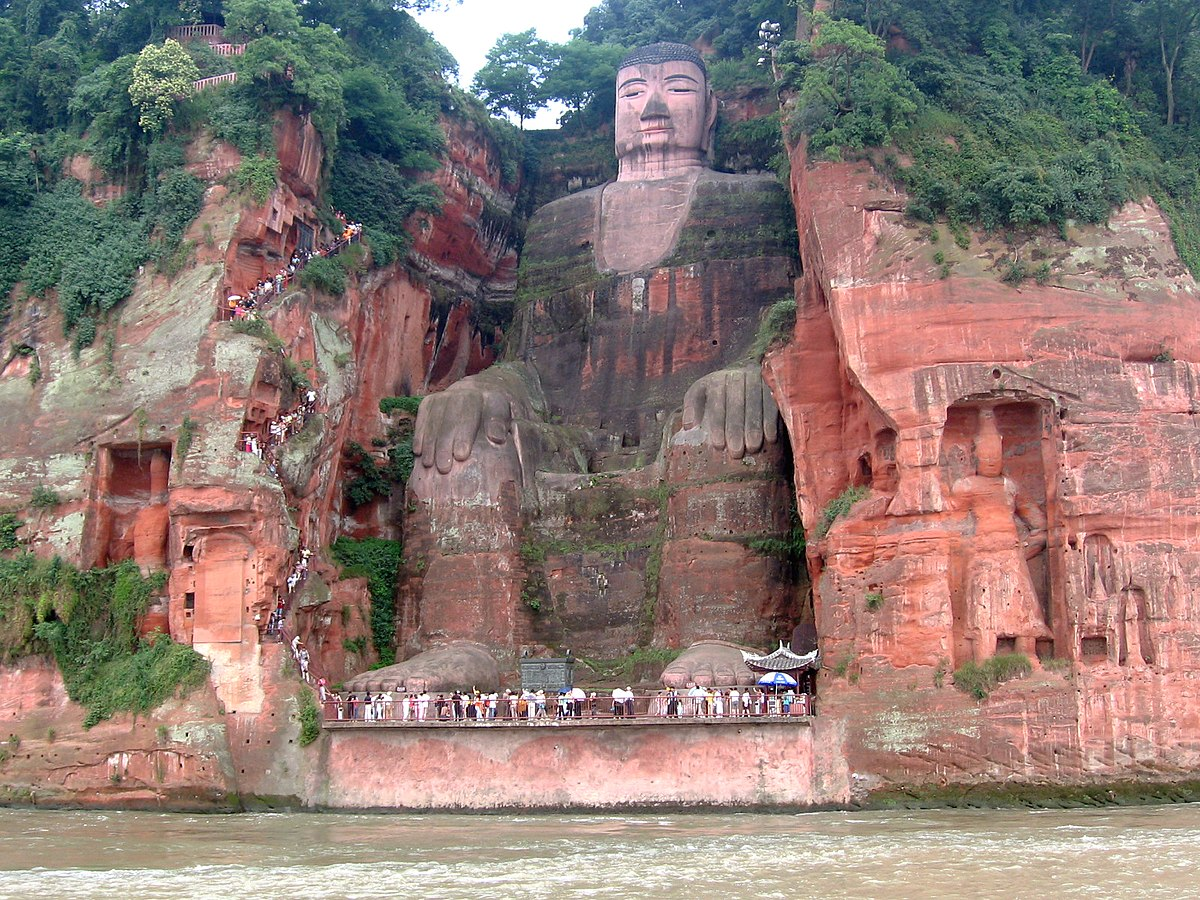Can you tell more about the history of the Leshan Giant Buddha? Certainly! The Leshan Giant Buddha was constructed during the Tang Dynasty, beginning in the 8th century and completed in the early 9th century. It was commissioned by a monk named Haitong, who hoped that the Buddha would calm the turbulent waters of the river below. The project was an immense undertaking, involving thousands of workers and the removal of huge quantities of rock. Its completion is a testament to the devotion and persistence of its builders. 